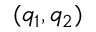Convert formula to latex. <formula><loc_0><loc_0><loc_500><loc_500>( q _ { 1 } , q _ { 2 } )</formula> 